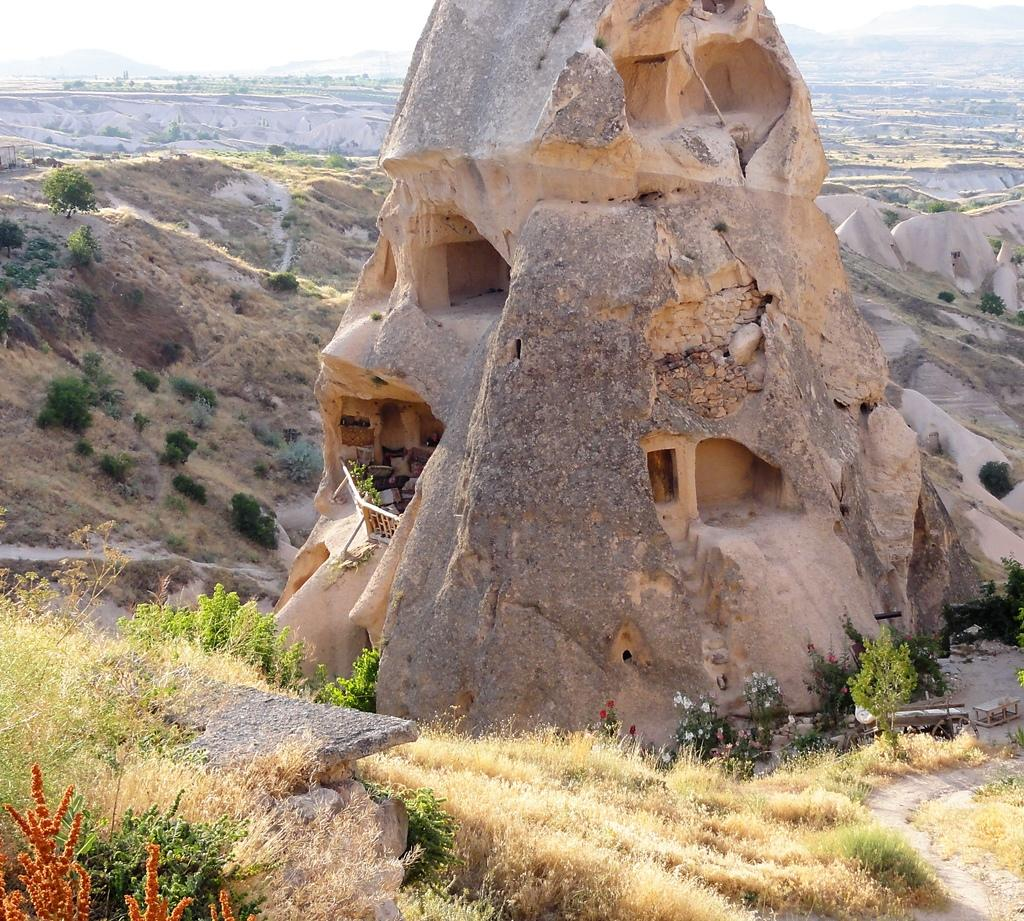What can be seen in the sky in the image? The sky is visible in the image. What type of natural features are present in the image? There are hills, rocks, plants, and shrubs visible in the image. What type of vegetation can be seen in the image? Grass is visible in the image. What time of day is it in the image? The provided facts do not specify the time of day, so it cannot be determined from the image. 